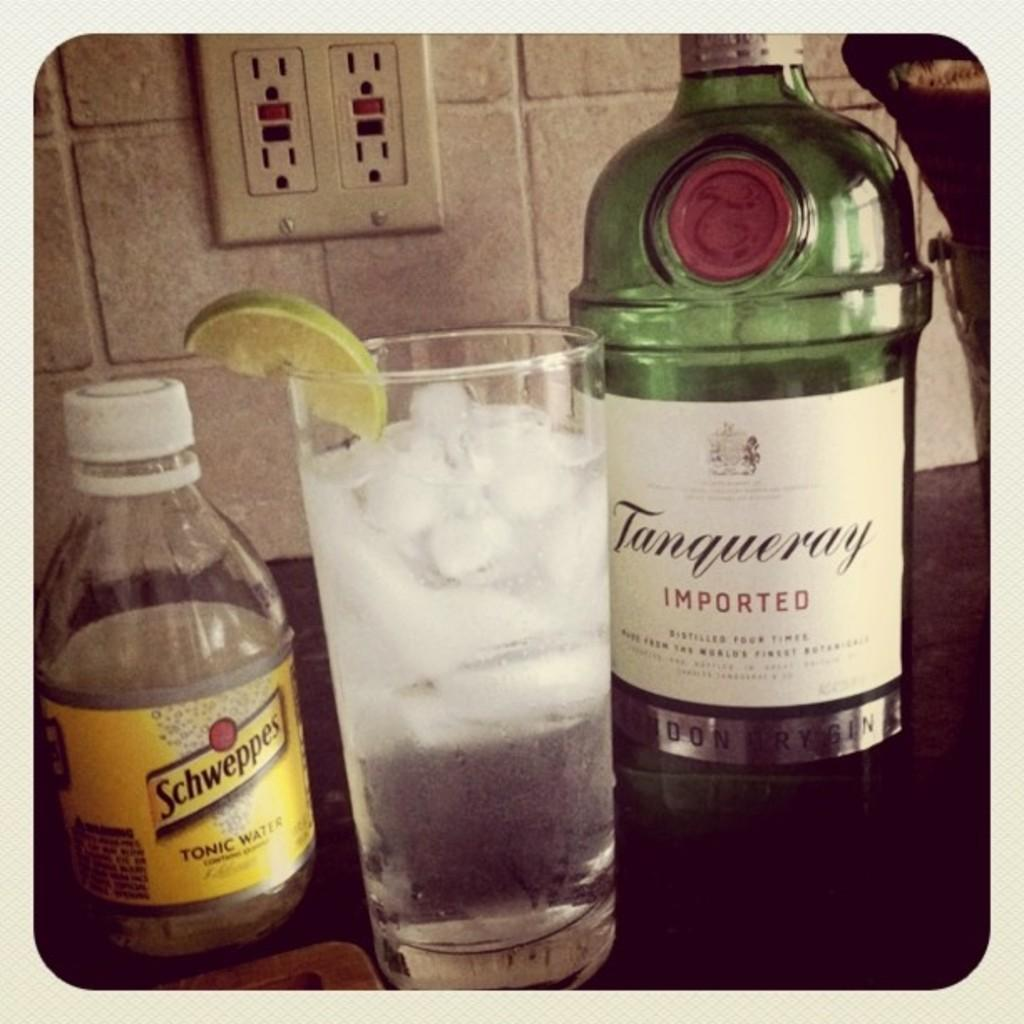<image>
Give a short and clear explanation of the subsequent image. A glass with a lime in it is next to a bottle that says Tangueray. 